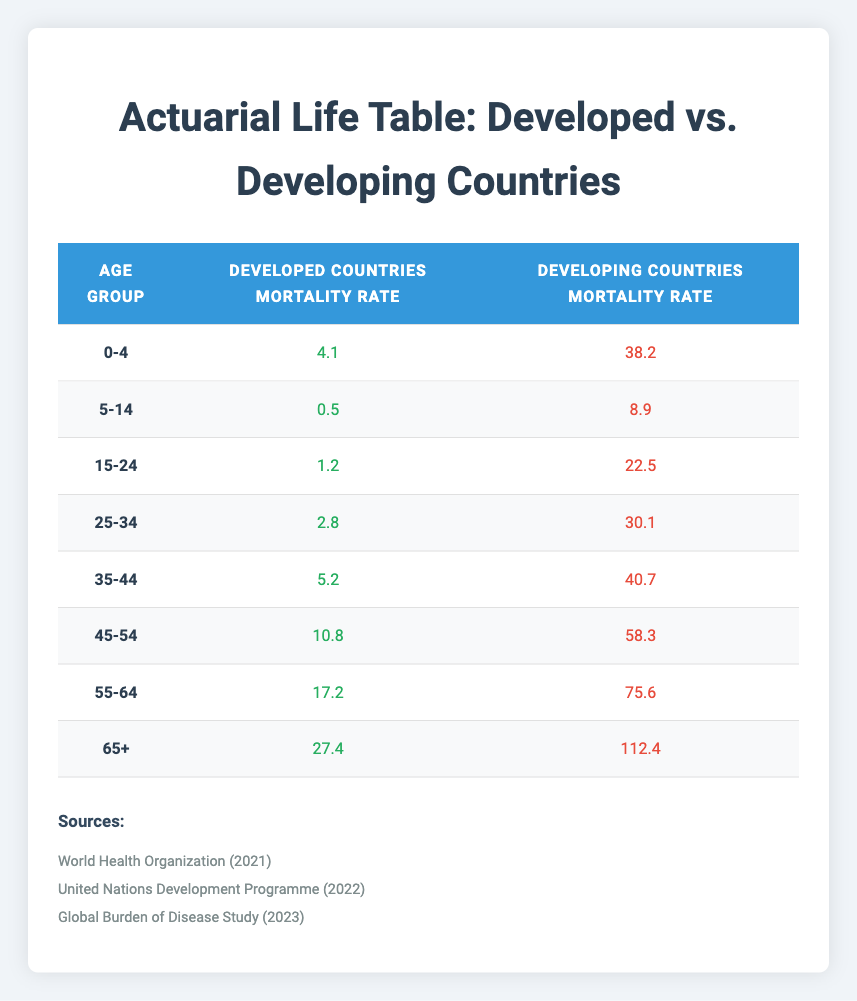What is the mortality rate for the age group 0-4 in developing countries? The table shows the mortality rate for the age group 0-4 specifically for developing countries, which is listed as 38.2.
Answer: 38.2 What is the difference in mortality rates for the age group 15-24 between developed and developing countries? The mortality rate for developed countries in the 15-24 age group is 1.2, while for developing countries, it is 22.5. The difference is 22.5 - 1.2 = 21.3.
Answer: 21.3 Is the mortality rate for the age group 45-54 higher in developed or developing countries? The table indicates the mortality rate for the age group 45-54 in developed countries is 10.8 and in developing countries is 58.3. Since 58.3 is greater than 10.8, the mortality rate is higher in developing countries.
Answer: Yes What is the average mortality rate for the age group 25-34 across both developed and developing countries? To find the average, sum the mortality rates: 2.8 (developed) + 30.1 (developing) = 32.9, and then divide by 2. So, the average is 32.9 / 2 = 16.45.
Answer: 16.45 Which age group has the highest mortality rate in developed countries? By examining the developed countries' mortality rates, the age group 65+ has the highest rate at 27.4, which is greater than all other age groups listed.
Answer: 65+ What is the total mortality rate for the age group 55-64 in developed countries and the age group 45-54 in developing countries? For developed countries, the age group 55-64 has a mortality rate of 17.2, and for developing countries, the age group 45-54 has a rate of 58.3. Adding these gives 17.2 + 58.3 = 75.5.
Answer: 75.5 Is it true that the mortality rate increases with age in both developed and developing countries? Observing the table, it shows that as the age increases, the mortality rates for both developed and developing countries consistently rise. Therefore, this statement is true.
Answer: Yes What is the sum of the mortality rates for the age groups 5-14 and 15-24 in developed countries? The mortality rate for 5-14 is 0.5 and for 15-24 is 1.2. Summing these rates gives 0.5 + 1.2 = 1.7.
Answer: 1.7 